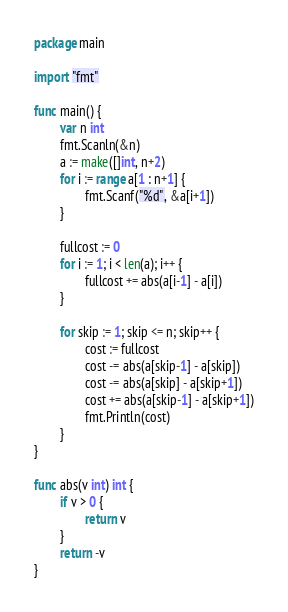<code> <loc_0><loc_0><loc_500><loc_500><_Go_>package main

import "fmt"

func main() {
        var n int
        fmt.Scanln(&n)
        a := make([]int, n+2)
        for i := range a[1 : n+1] {
                fmt.Scanf("%d", &a[i+1])
        }

        fullcost := 0
        for i := 1; i < len(a); i++ {
                fullcost += abs(a[i-1] - a[i])
        }

        for skip := 1; skip <= n; skip++ {
                cost := fullcost
                cost -= abs(a[skip-1] - a[skip])
                cost -= abs(a[skip] - a[skip+1])
                cost += abs(a[skip-1] - a[skip+1])
                fmt.Println(cost)
        }
}

func abs(v int) int {
        if v > 0 {
                return v
        }
        return -v
}</code> 